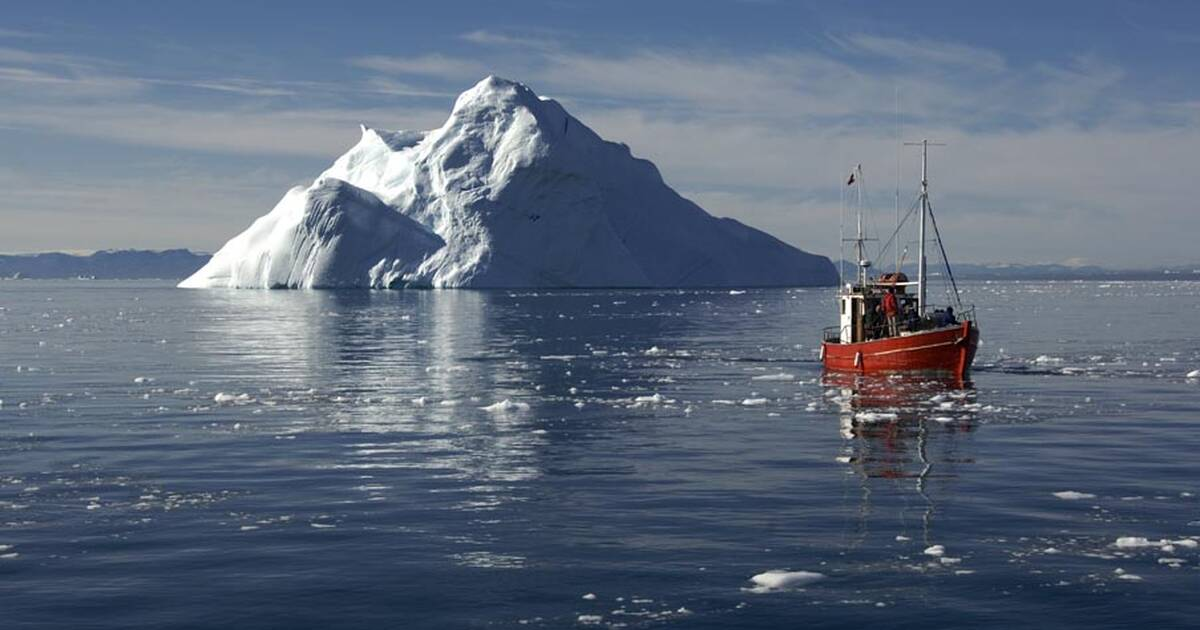Can you create a poem inspired by this scene? Amidst the Arctic's icy dream,
Where fjords whisper, glaciers gleam,
A lone red vessel braves the sea,
A dance of man and nature's plea.

The iceberg's majesty ascends,
White peaks where sky and ocean blend.
Beneath, the secrets deep and cold,
Tales of a million years untold.

The waters, blue as twilight's eye,
Reflect the boat, a crimson sigh.
A journey carved 'twixt ice and wave,
Where Neptune's ancient watchers brave.

Silent whispers, frozen tales,
Of seafarers and icy gales,
Echo through the frigid air,
A testament to those who dare.

Floating heart of ancient ice,
Guardian of this paradise,
In your shadow, man does sail,
A fleeting mark in nature's tale. 